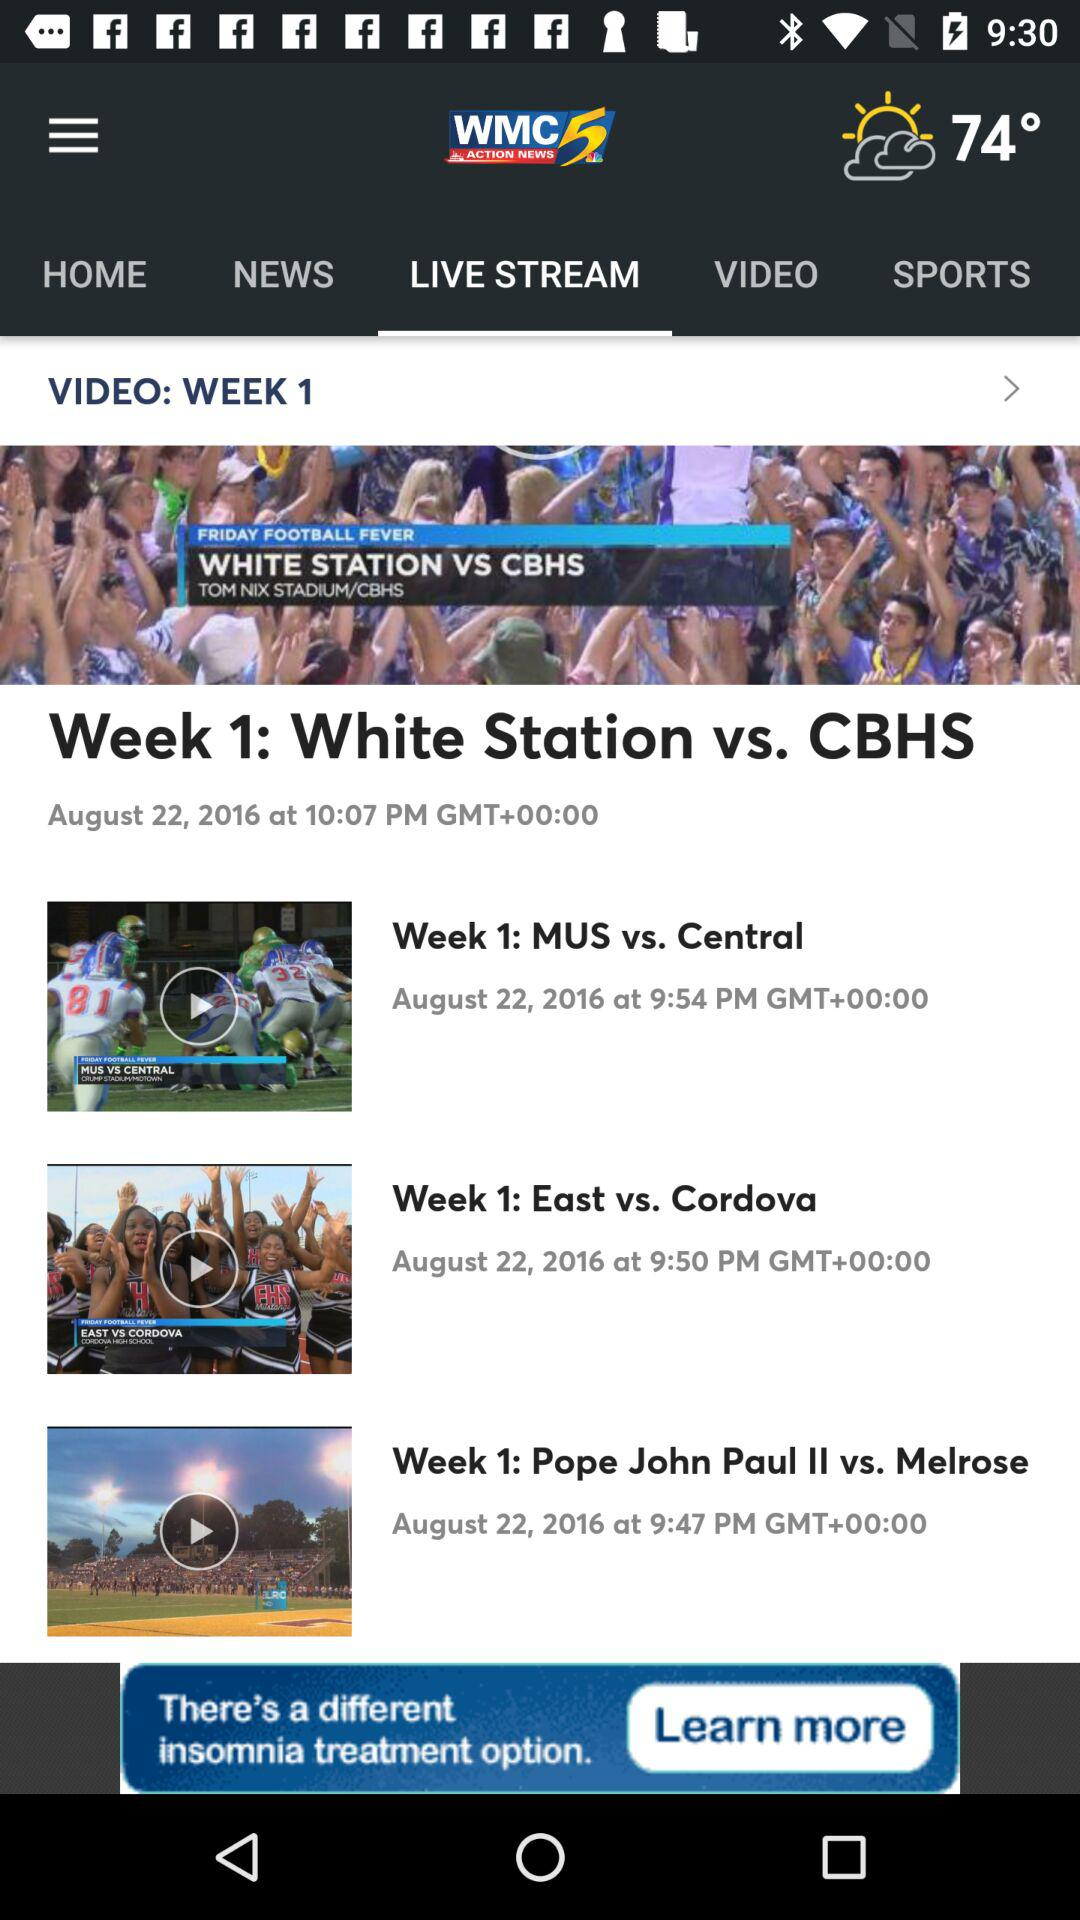Whose match is at 9:54 pm? The match between MUS vs. Central is at 9:54 pm. 